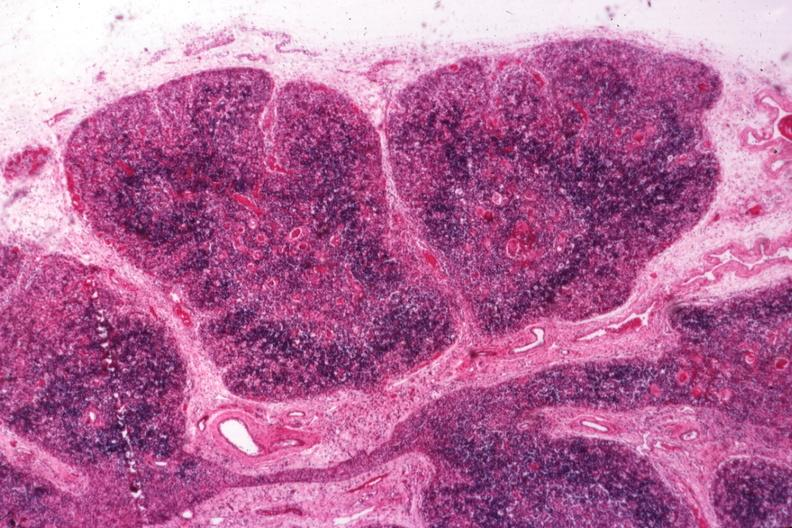does face show typical atrophy associated with infection in newborn?
Answer the question using a single word or phrase. No 